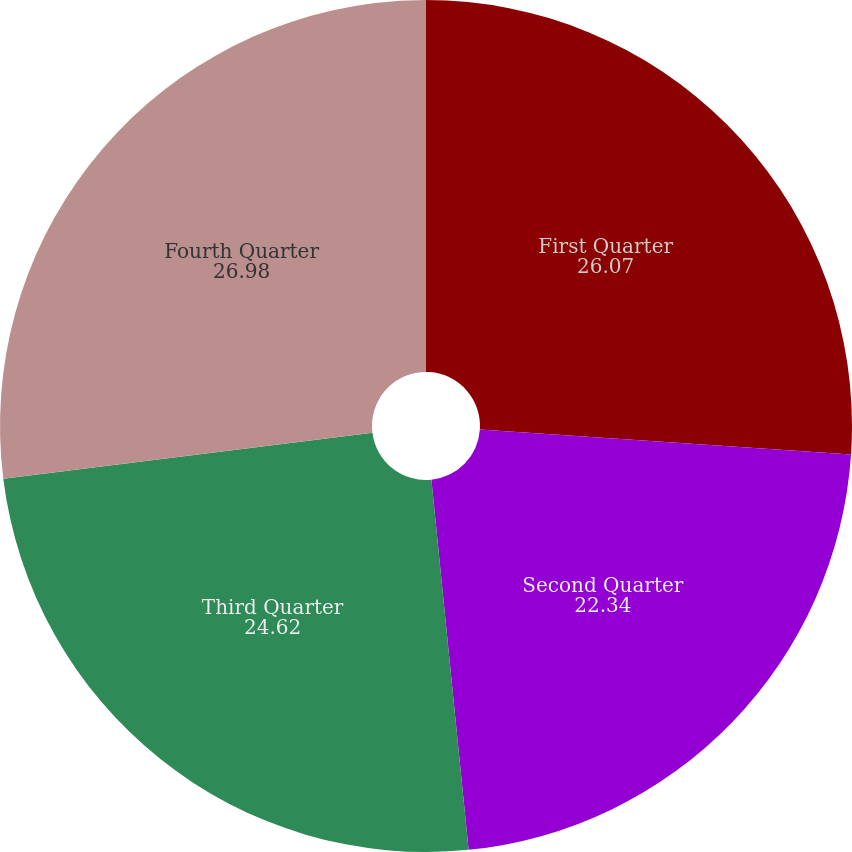Convert chart. <chart><loc_0><loc_0><loc_500><loc_500><pie_chart><fcel>First Quarter<fcel>Second Quarter<fcel>Third Quarter<fcel>Fourth Quarter<nl><fcel>26.07%<fcel>22.34%<fcel>24.62%<fcel>26.98%<nl></chart> 